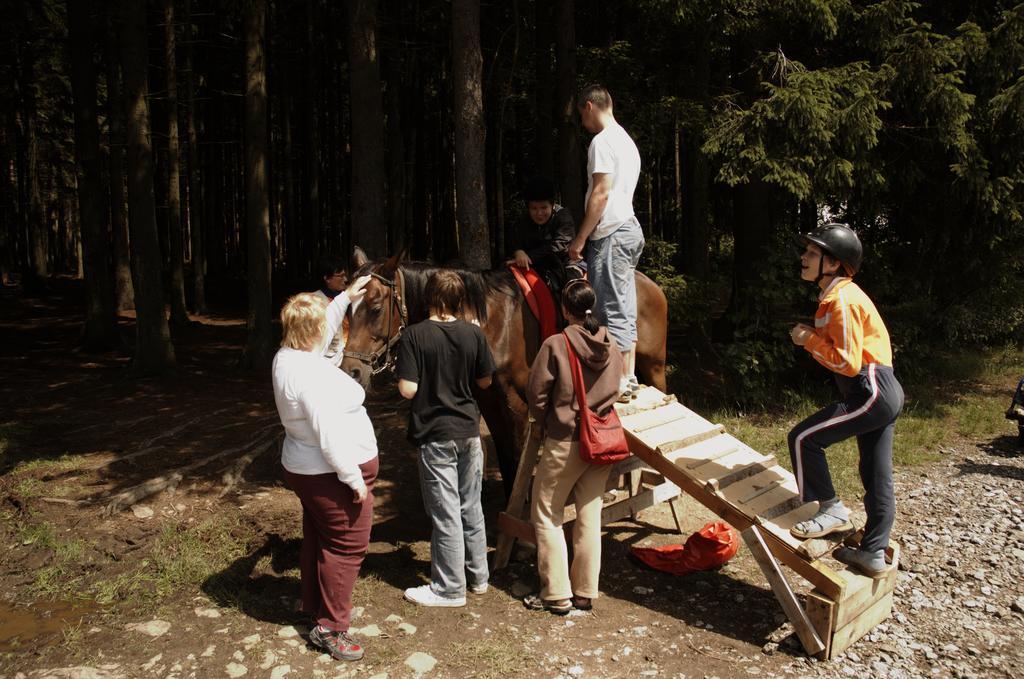Please provide a concise description of this image. In the center of the image we can see persons and horse. On the right side of the image we can see person, stones and trees. In the background we can see trees. 